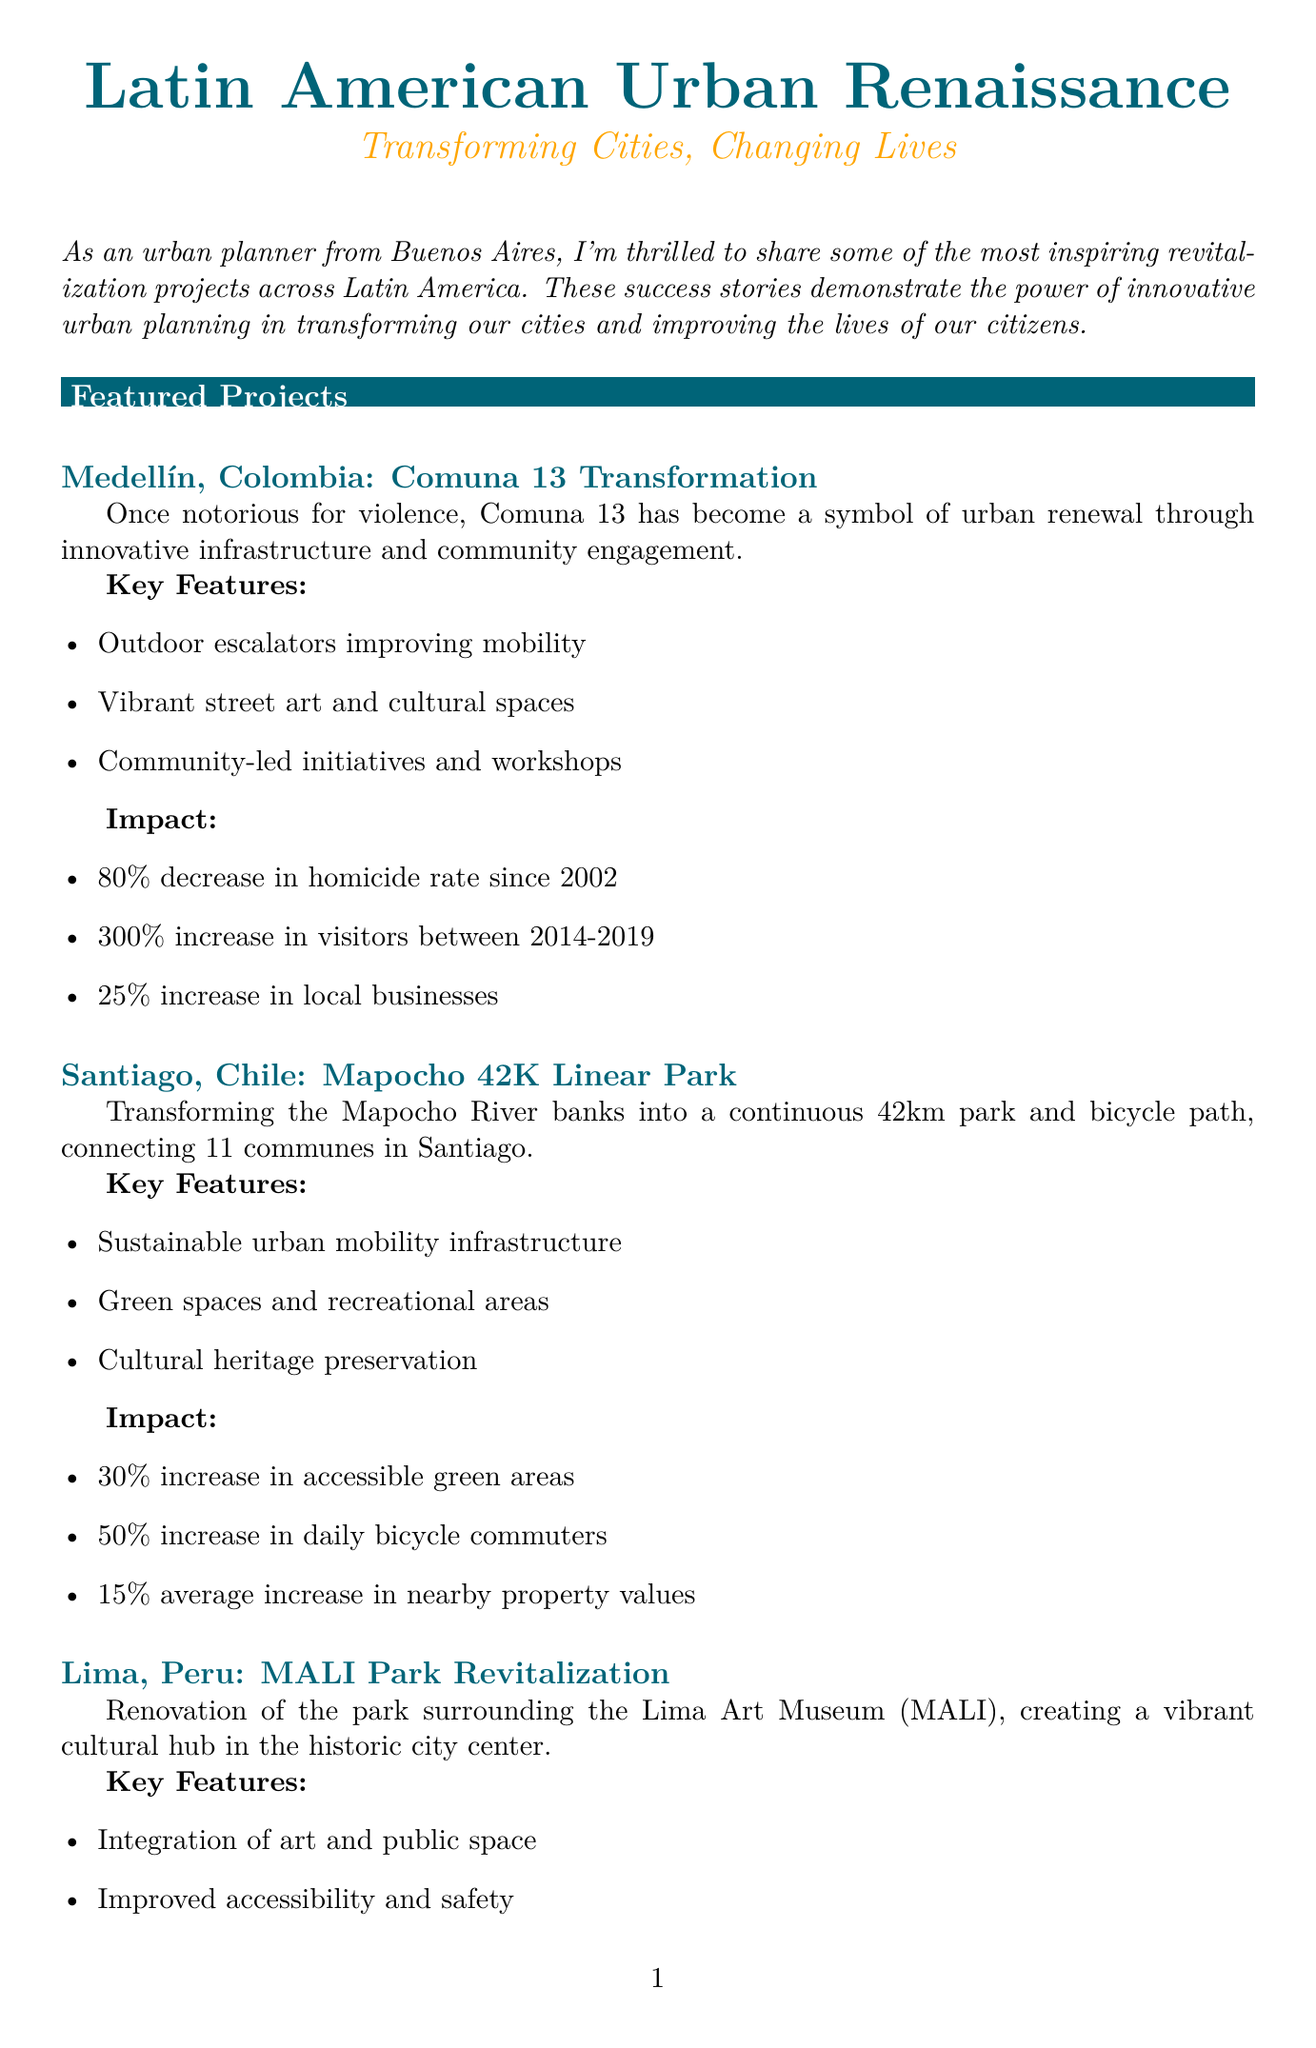What city is known for the Comuna 13 Transformation? The document lists Medellín, Colombia as the city for the Comuna 13 Transformation project.
Answer: Medellín, Colombia What is the percentage decrease in the homicide rate in Comuna 13 since 2002? The document states that there was an 80% decrease in the homicide rate since 2002 in Comuna 13.
Answer: 80% What key feature improves mobility in Comuna 13? The document mentions outdoor escalators as a key feature that improves mobility.
Answer: Outdoor escalators How long is the Mapocho 42K Linear Park? The project description states that the Mapocho 42K Linear Park is 42 kilometers long.
Answer: 42km What percentage increase in daily bicycle commuters was reported after the Mapocho 42K project? The document specifies a 50% increase in daily bicycle commuters following the project.
Answer: 50% How many cultural events are hosted annually in MALI Park after revitalization? According to the document, MALI Park hosts 50 cultural events annually after its revitalization.
Answer: 50 What type of experts provided insights in the newsletter? The document includes insights from a Professor of Urban Studies and a Director of an Urban Studies Center.
Answer: Urban experts Which city experienced a 200% increase in park visitors? The document indicates that Lima, Peru saw a 200% increase in park visitors after the MALI Park revitalization.
Answer: Lima, Peru What is the focus of the upcoming webinar mentioned in the newsletter? The document highlights the focus of the webinar as successful urban revitalization strategies in Buenos Aires.
Answer: Urban revitalization strategies 